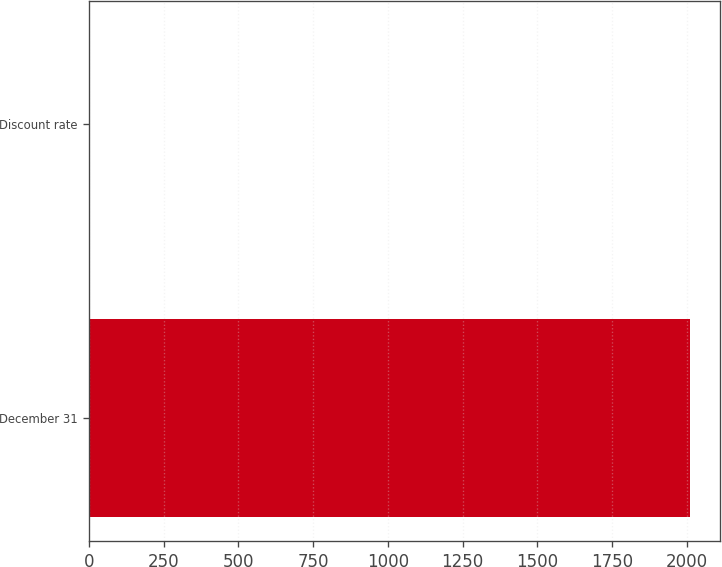Convert chart. <chart><loc_0><loc_0><loc_500><loc_500><bar_chart><fcel>December 31<fcel>Discount rate<nl><fcel>2012<fcel>3.6<nl></chart> 